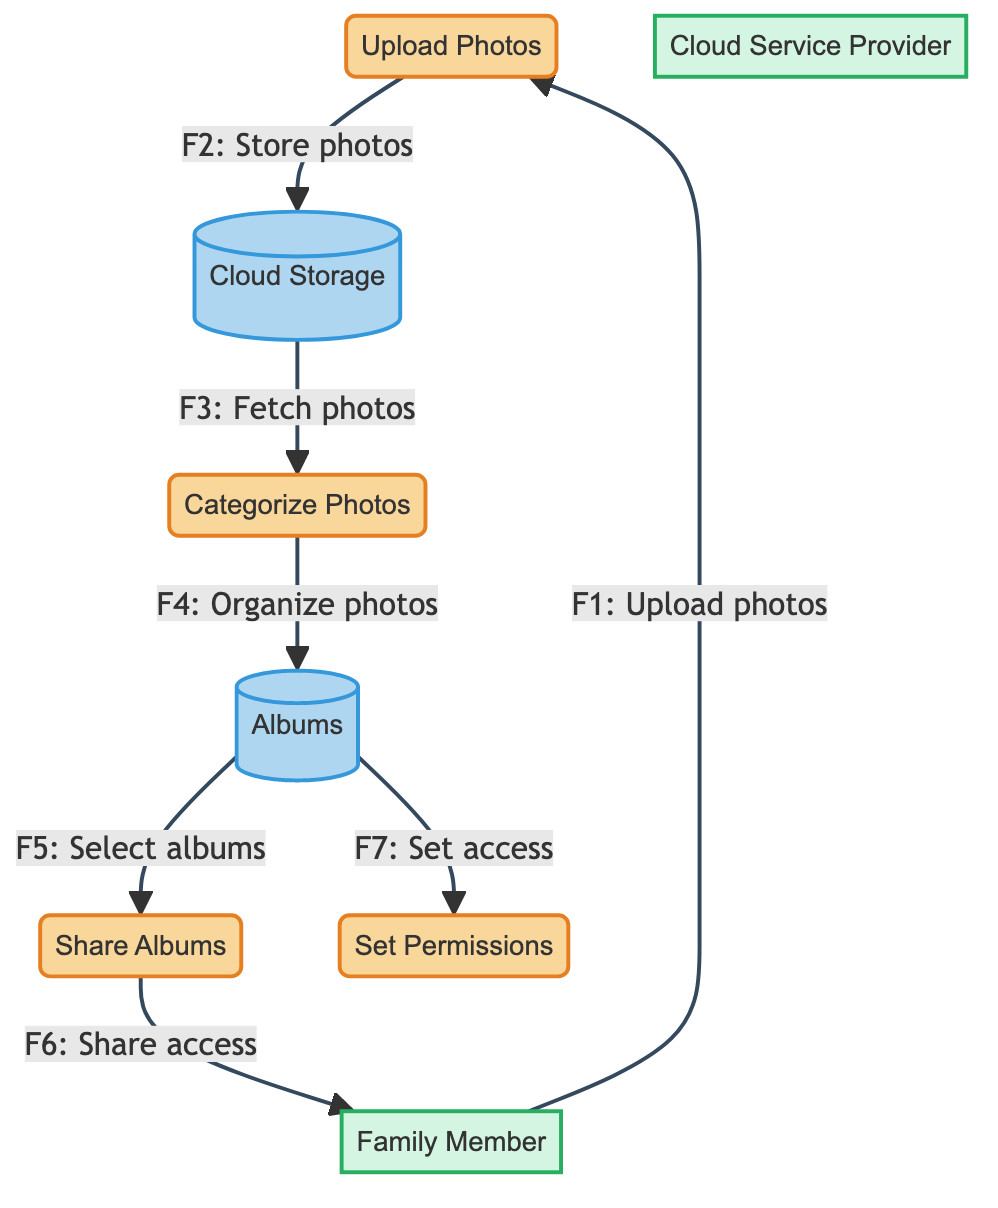What is the first process in the diagram? The first process listed in the diagram is "Upload Photos," which is the initial step where family members contribute their photos to the cloud storage service.
Answer: Upload Photos How many data stores are present in the diagram? There are two data stores shown, "Cloud Storage" and "Albums," which are essential for organizing and retaining the photos uploaded by family members.
Answer: 2 What is the destination of the data flow from "Categorize Photos"? The data flow from "Categorize Photos" moves to "Albums," indicating that structured photos are then organized and placed in the appropriate digital albums.
Answer: Albums Which external entity uploads photos according to the diagram? The external entity responsible for uploading photos is identified as "Family Member," reflecting the active participation of family members in the photo-sharing process.
Answer: Family Member What process follows "Set Permissions" in the workflow? In the workflow, "Set Permissions" is not directly followed by another process, but it is interconnected with "Albums," emphasizing the role of access management after photo categorization.
Answer: Albums What type of flow connects the "Upload Photos" process to the "Cloud Storage"? The flow connecting these two elements is described as "Store photos," showing the action of transferring uploaded images into the central storage repository.
Answer: Store photos How is sharing managed in the diagram? Sharing is managed through the "Share Albums" process, which selects certain albums for distribution to family members, effectively facilitating collaborative access to photo collections.
Answer: Share Albums Which process is linked to setting access permissions? The process linked to setting access permissions is "Set Permissions," indicating its role in determining who can see or interact with the uploaded and organized photo albums.
Answer: Set Permissions What does the "Cloud Service Provider" represent in the diagram? The "Cloud Service Provider" represents the external entity that oversees the infrastructure and management of the cloud storage service utilized for photo organization and sharing.
Answer: Cloud Service Provider 